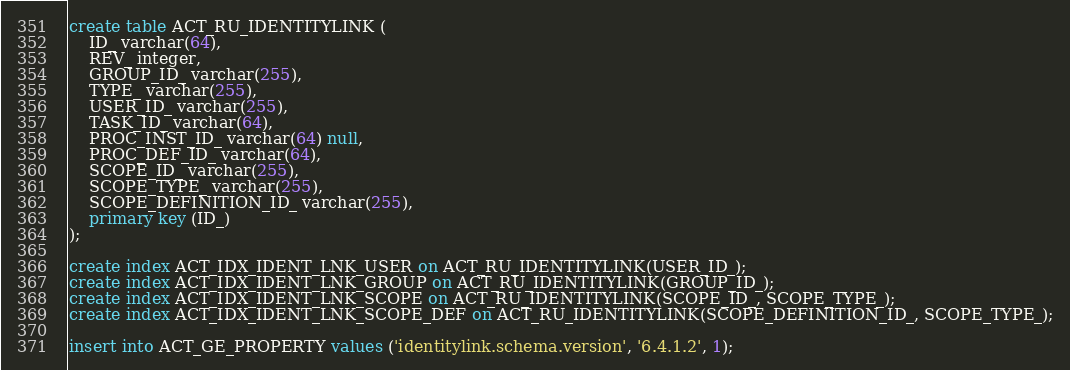<code> <loc_0><loc_0><loc_500><loc_500><_SQL_>create table ACT_RU_IDENTITYLINK (
    ID_ varchar(64),
    REV_ integer,
    GROUP_ID_ varchar(255),
    TYPE_ varchar(255),
    USER_ID_ varchar(255),
    TASK_ID_ varchar(64),
    PROC_INST_ID_ varchar(64) null,
    PROC_DEF_ID_ varchar(64),
    SCOPE_ID_ varchar(255),
    SCOPE_TYPE_ varchar(255),
    SCOPE_DEFINITION_ID_ varchar(255),
    primary key (ID_)
);

create index ACT_IDX_IDENT_LNK_USER on ACT_RU_IDENTITYLINK(USER_ID_);
create index ACT_IDX_IDENT_LNK_GROUP on ACT_RU_IDENTITYLINK(GROUP_ID_);
create index ACT_IDX_IDENT_LNK_SCOPE on ACT_RU_IDENTITYLINK(SCOPE_ID_, SCOPE_TYPE_);
create index ACT_IDX_IDENT_LNK_SCOPE_DEF on ACT_RU_IDENTITYLINK(SCOPE_DEFINITION_ID_, SCOPE_TYPE_);

insert into ACT_GE_PROPERTY values ('identitylink.schema.version', '6.4.1.2', 1);</code> 